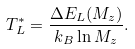<formula> <loc_0><loc_0><loc_500><loc_500>T _ { L } ^ { * } = \frac { \Delta E _ { L } ( M _ { z } ) } { k _ { B } \ln M _ { z } } .</formula> 